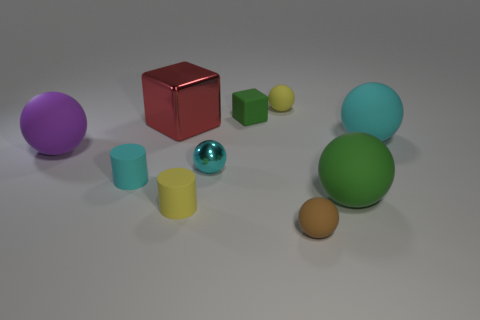Subtract all small cyan metallic balls. How many balls are left? 5 Subtract all cyan balls. Subtract all cyan cubes. How many balls are left? 4 Subtract all red balls. How many brown cylinders are left? 0 Subtract all yellow cylinders. How many cylinders are left? 1 Subtract all cylinders. How many objects are left? 8 Subtract 1 cylinders. How many cylinders are left? 1 Subtract all purple rubber things. Subtract all tiny metal spheres. How many objects are left? 8 Add 3 cubes. How many cubes are left? 5 Add 3 brown spheres. How many brown spheres exist? 4 Subtract 1 green spheres. How many objects are left? 9 